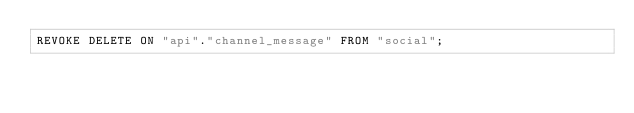<code> <loc_0><loc_0><loc_500><loc_500><_SQL_>REVOKE DELETE ON "api"."channel_message" FROM "social";</code> 